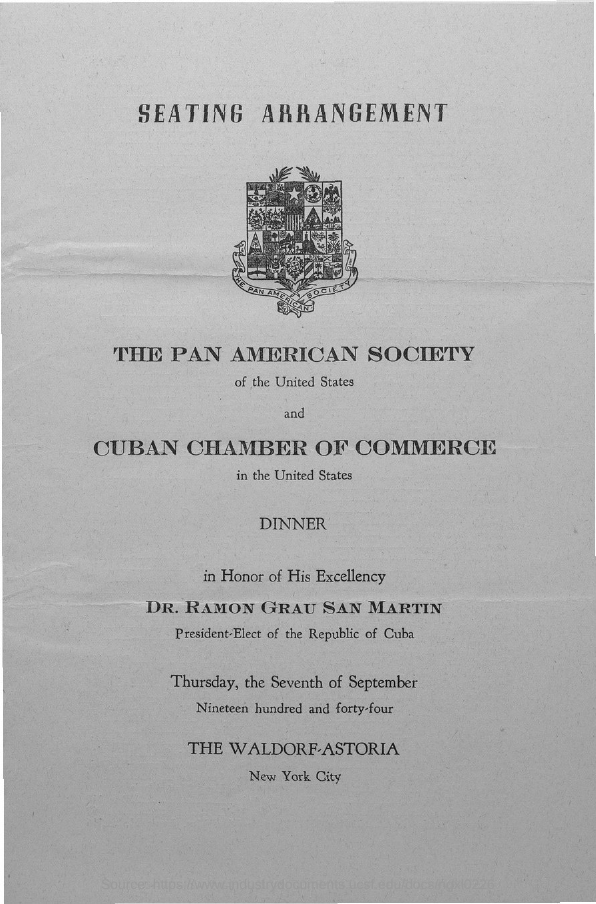List a handful of essential elements in this visual. The first title in the document is 'Seating Arrangement.' 